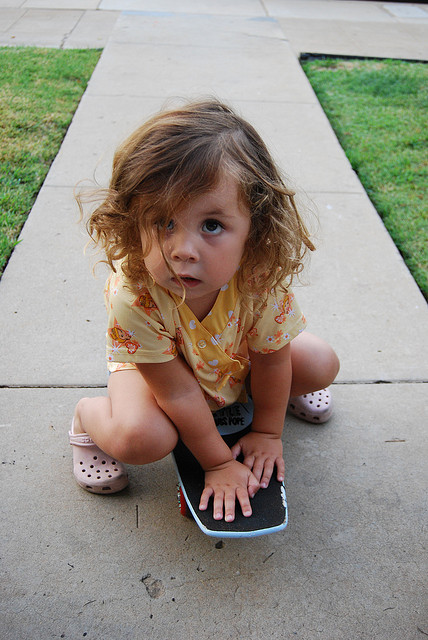Please extract the text content from this image. NOPE 